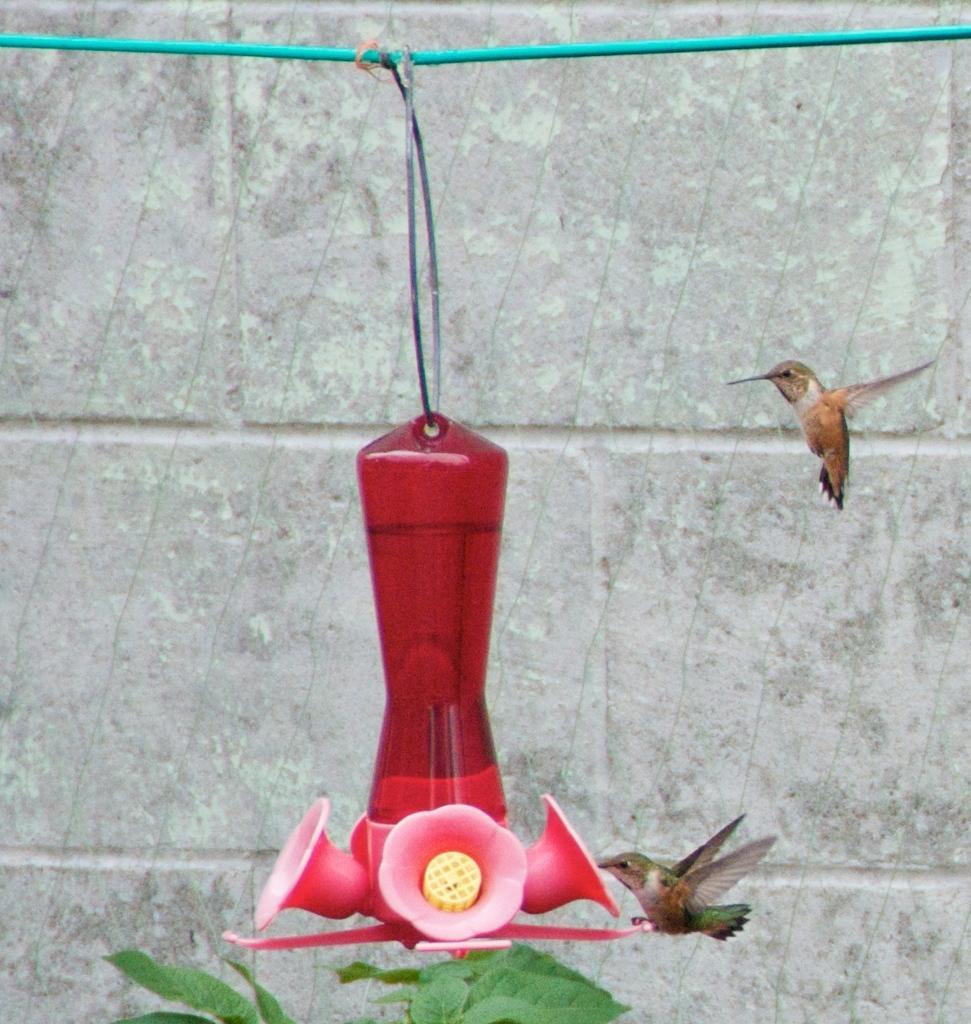Can you describe this image briefly? In this image we can see a container tied with a string on a wire. To the right side we can see two birds flying. In the foreground we can see a plant. In the background we can see a wall. 